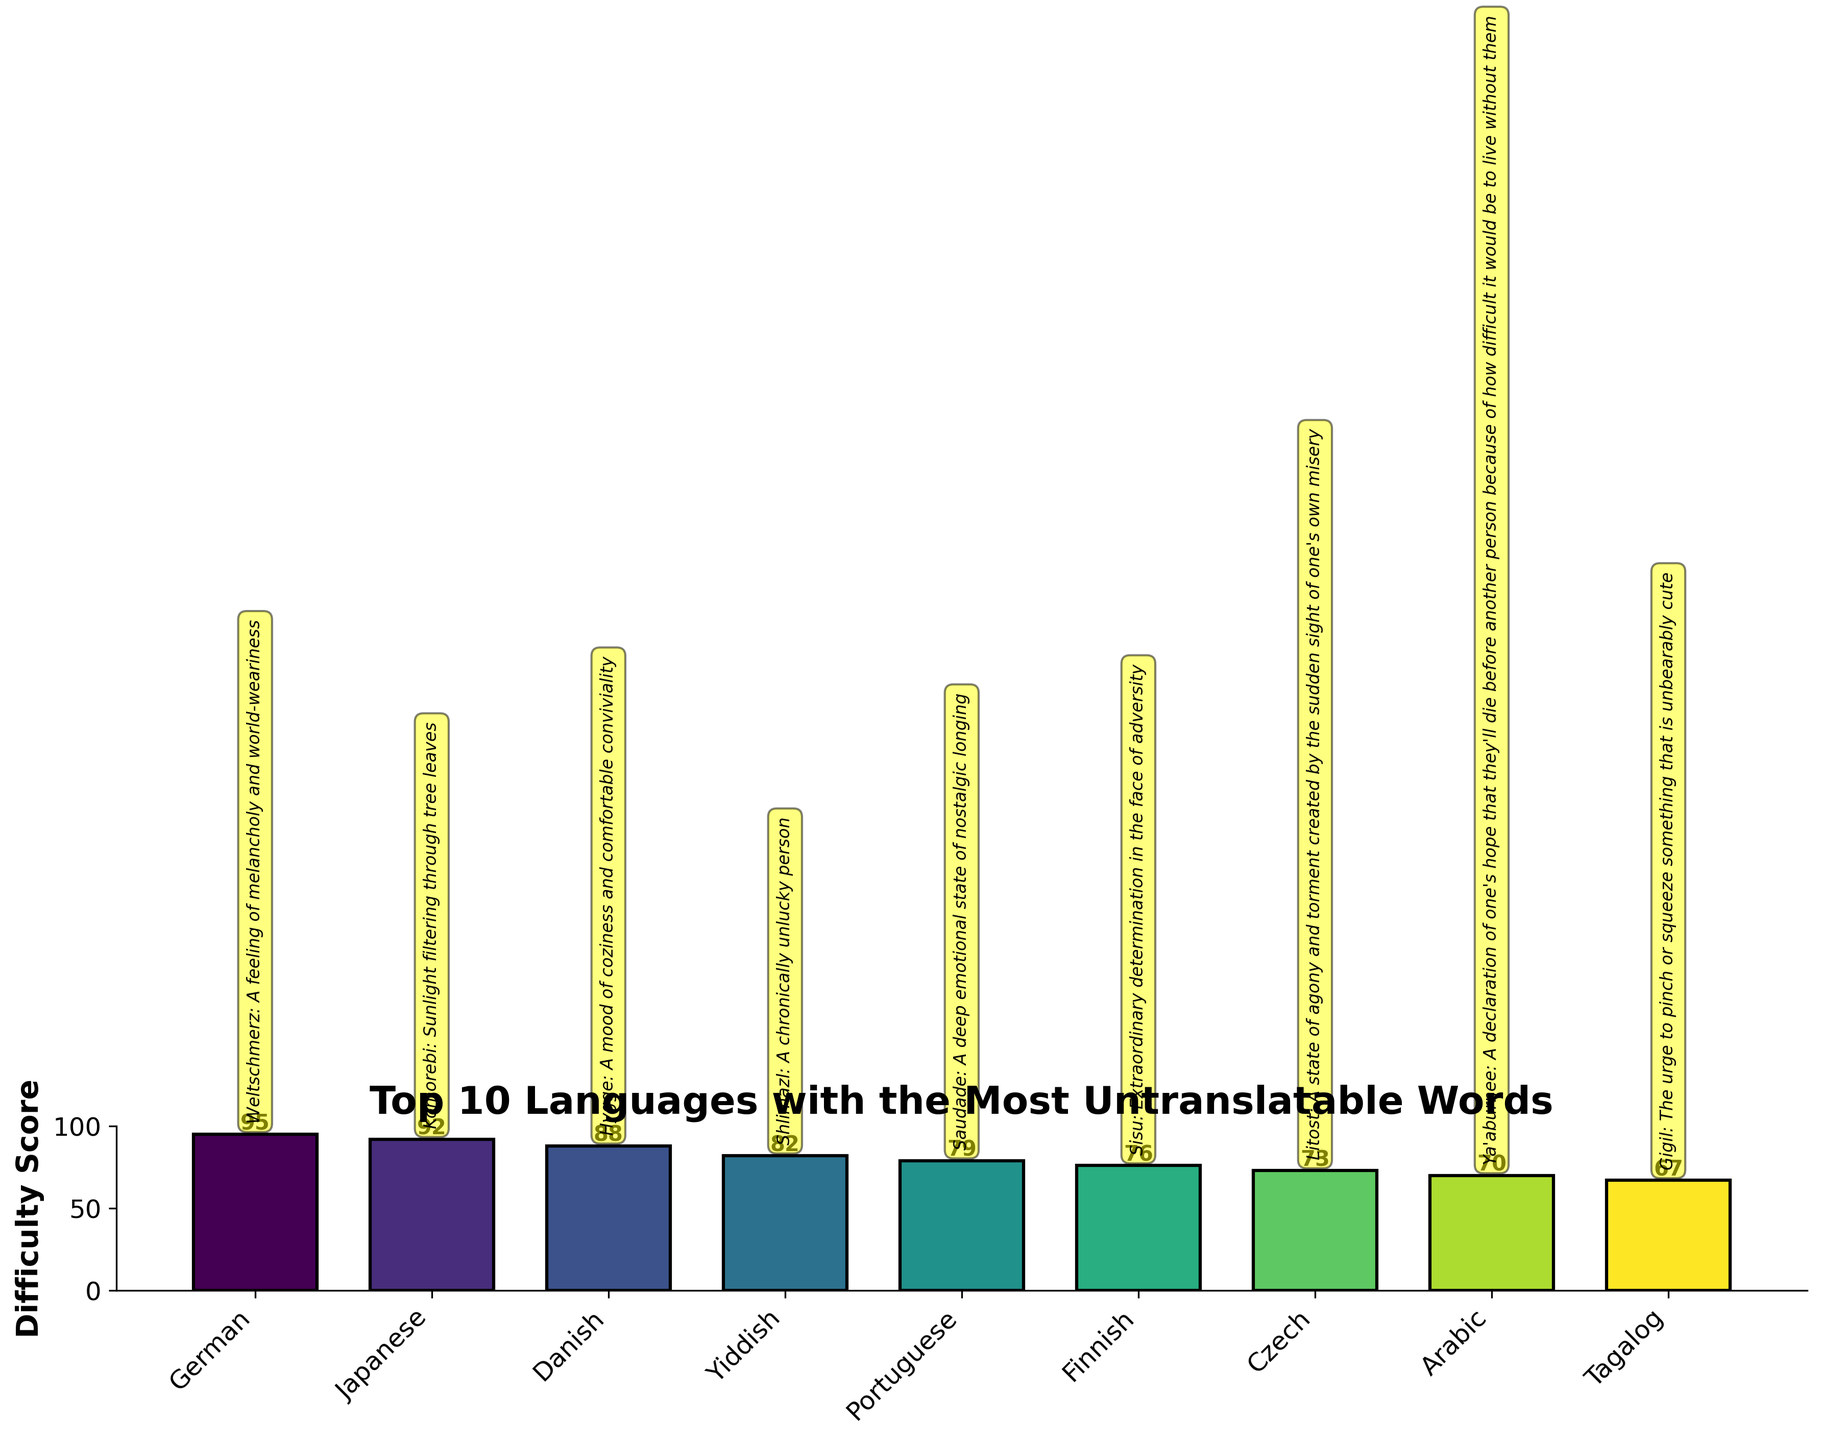What language has the most untranslatable words based on the difficulty score? The highest bar in the plot represents the language with the most untranslatable words, which correlates with the highest difficulty score. Looking at the bar chart, the German language has the tallest bar with a difficulty score of 95.
Answer: German Which language ranks second in terms of untranslatable words? The second tallest bar in the chart represents the language with the second highest difficulty score. It is the Japanese language, with a difficulty score of 92.
Answer: Japanese What is the difficulty score for Finnish? Identify the bar labeled "Finnish" and look at the numeral above it which indicates the difficulty score. The score is 76.
Answer: 76 Which language has a lower difficulty score: Portuguese or Arabic? Compare the heights of the bars labeled "Portuguese" and "Arabic". The chart shows Portuguese has a score of 79 and Arabic has a score of 70.
Answer: Arabic What is the sum of difficulty scores for German, Danish, and Yiddish? Add the difficulty scores of German (95), Danish (88), and Yiddish (82). The total is 95 + 88 + 82 = 265.
Answer: 265 How many languages have a difficulty score above 80? Count the bars with heights indicating scores above 80. The languages are German, Japanese, Danish, and Yiddish, so there are 4.
Answer: 4 Which word represents a feeling of coziness and comfortable conviviality? Identify the word associated with the Danish language. The annotation on the bar chart shows the word "Hygge" with this meaning.
Answer: Hygge Is the difficulty score for Czech higher or lower than Tagalog? Compare the bars representing Czech and Tagalog. Czech has a difficulty score of 73, which is higher than Tagalog's 67.
Answer: Higher Do more languages have difficulty scores above or below 75? Count the number of languages with scores above 75 (6 languages: German, Japanese, Danish, Yiddish, Portuguese, Finnish) versus those below 75 (4 languages: Czech, Arabic, Tagalog).
Answer: Above What is the average difficulty score of the top 5 languages? Add the difficulty scores of the top 5 languages (German, Japanese, Danish, Yiddish, Portuguese) and then divide by 5. The sum is 95 + 92 + 88 + 82 + 79 = 436. The average is 436 / 5 = 87.2.
Answer: 87.2 